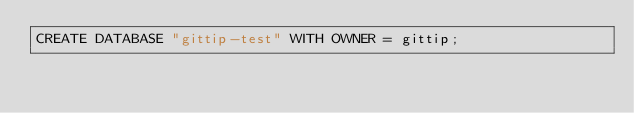<code> <loc_0><loc_0><loc_500><loc_500><_SQL_>CREATE DATABASE "gittip-test" WITH OWNER = gittip;
</code> 